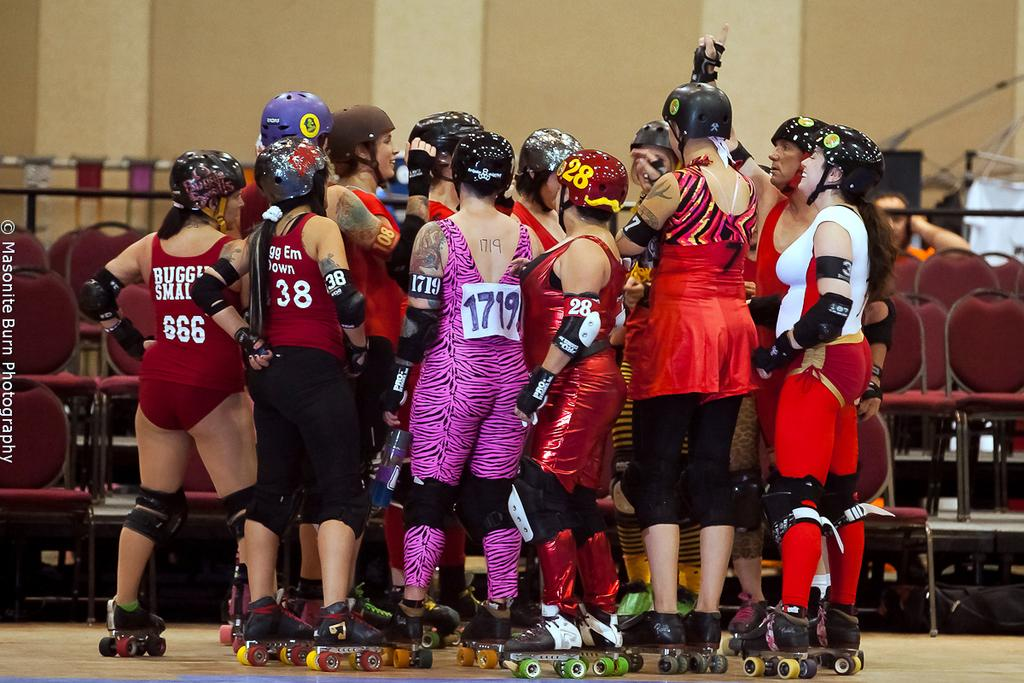<image>
Give a short and clear explanation of the subsequent image. One of the women on roller skates has Buggy Small on the back of her costume. 